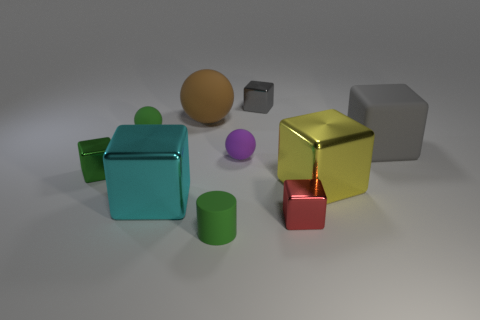Subtract 1 spheres. How many spheres are left? 2 Subtract all green cubes. How many cubes are left? 5 Subtract all tiny green cubes. How many cubes are left? 5 Subtract all brown cubes. Subtract all yellow cylinders. How many cubes are left? 6 Subtract all blocks. How many objects are left? 4 Subtract 1 purple spheres. How many objects are left? 9 Subtract all tiny purple metallic things. Subtract all tiny purple rubber balls. How many objects are left? 9 Add 5 cyan metal cubes. How many cyan metal cubes are left? 6 Add 5 tiny cyan objects. How many tiny cyan objects exist? 5 